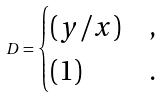Convert formula to latex. <formula><loc_0><loc_0><loc_500><loc_500>D = \begin{cases} ( y / x ) & , \\ ( 1 ) & . \end{cases}</formula> 